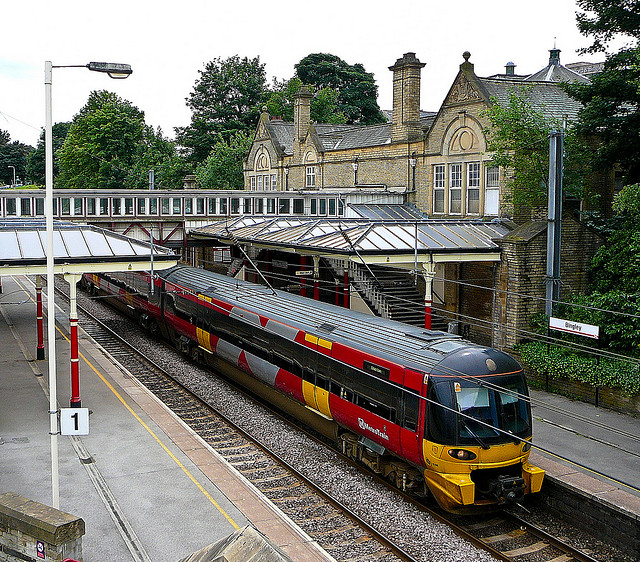Identify the text contained in this image. 1 